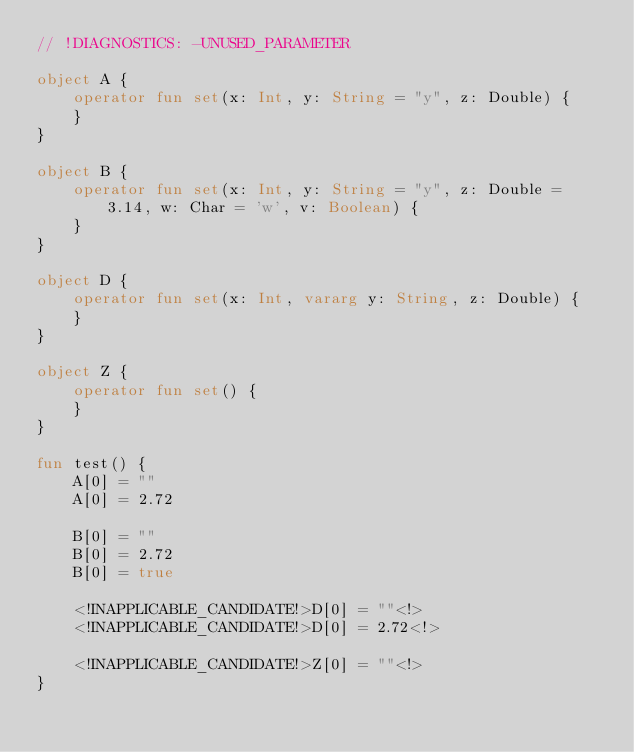<code> <loc_0><loc_0><loc_500><loc_500><_Kotlin_>// !DIAGNOSTICS: -UNUSED_PARAMETER

object A {
    operator fun set(x: Int, y: String = "y", z: Double) {
    }
}

object B {
    operator fun set(x: Int, y: String = "y", z: Double = 3.14, w: Char = 'w', v: Boolean) {
    }
}

object D {
    operator fun set(x: Int, vararg y: String, z: Double) {
    }
}

object Z {
    operator fun set() {
    }
}

fun test() {
    A[0] = ""
    A[0] = 2.72

    B[0] = ""
    B[0] = 2.72
    B[0] = true

    <!INAPPLICABLE_CANDIDATE!>D[0] = ""<!>
    <!INAPPLICABLE_CANDIDATE!>D[0] = 2.72<!>

    <!INAPPLICABLE_CANDIDATE!>Z[0] = ""<!>
}
</code> 